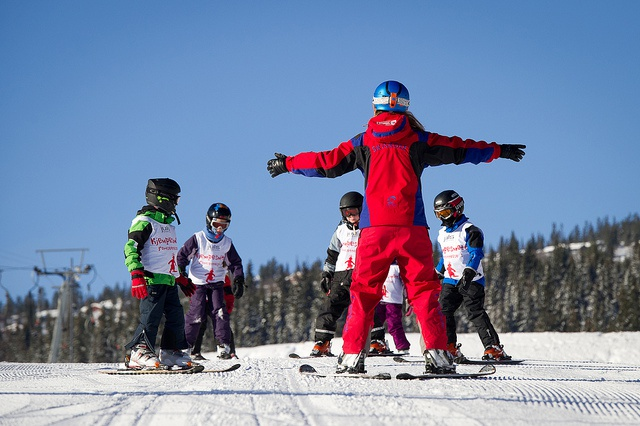Describe the objects in this image and their specific colors. I can see people in gray, red, maroon, black, and brown tones, people in gray, black, and darkgray tones, people in gray, black, darkgray, and lightgray tones, people in gray, black, white, and navy tones, and people in gray, black, white, and maroon tones in this image. 